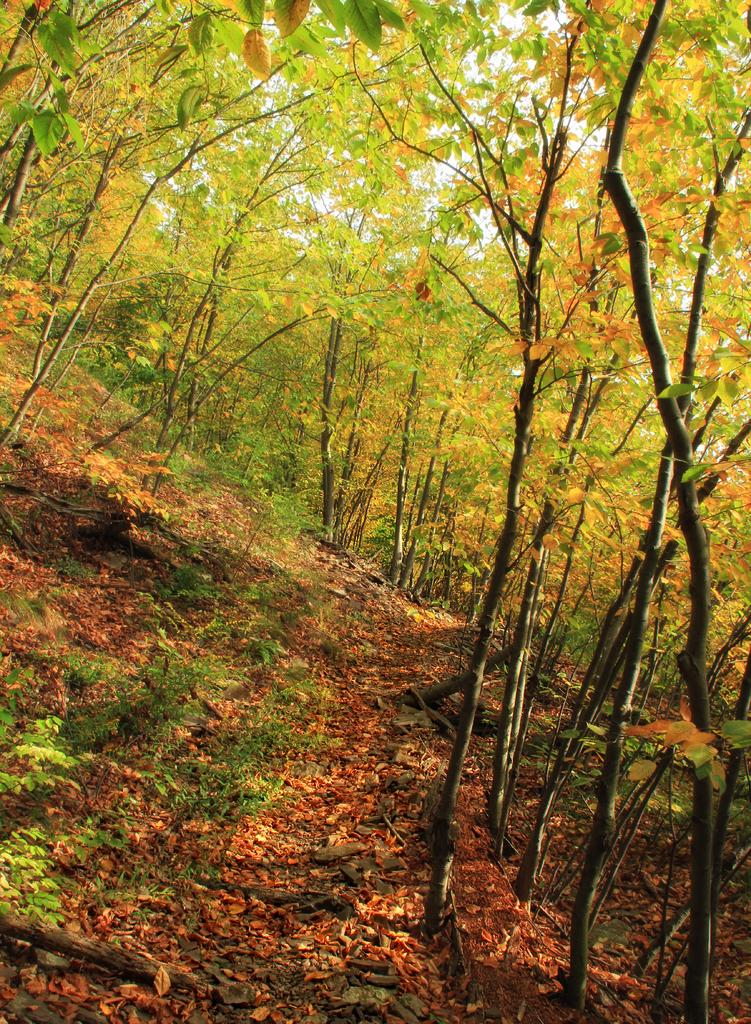What type of vegetation can be seen in the image? There are plants and trees visible in the image. What part of the plants can be observed in the image? Leaves are present in the image. What organization is responsible for the degree of the plants in the image? There is no organization or degree mentioned in the image; it simply shows plants and leaves. 